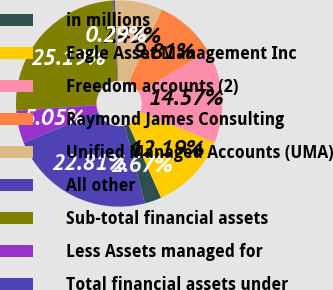<chart> <loc_0><loc_0><loc_500><loc_500><pie_chart><fcel>in millions<fcel>Eagle Asset Management Inc<fcel>Freedom accounts (2)<fcel>Raymond James Consulting<fcel>Unified Managed Accounts (UMA)<fcel>All other<fcel>Sub-total financial assets<fcel>Less Assets managed for<fcel>Total financial assets under<nl><fcel>2.67%<fcel>12.19%<fcel>14.57%<fcel>9.81%<fcel>7.43%<fcel>0.29%<fcel>25.19%<fcel>5.05%<fcel>22.81%<nl></chart> 